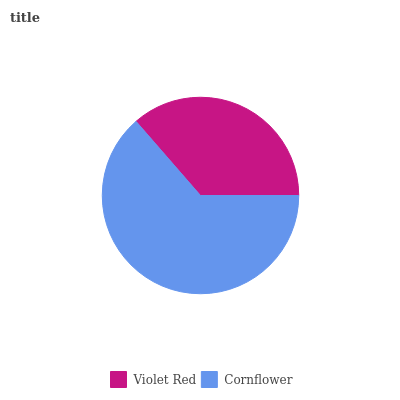Is Violet Red the minimum?
Answer yes or no. Yes. Is Cornflower the maximum?
Answer yes or no. Yes. Is Cornflower the minimum?
Answer yes or no. No. Is Cornflower greater than Violet Red?
Answer yes or no. Yes. Is Violet Red less than Cornflower?
Answer yes or no. Yes. Is Violet Red greater than Cornflower?
Answer yes or no. No. Is Cornflower less than Violet Red?
Answer yes or no. No. Is Cornflower the high median?
Answer yes or no. Yes. Is Violet Red the low median?
Answer yes or no. Yes. Is Violet Red the high median?
Answer yes or no. No. Is Cornflower the low median?
Answer yes or no. No. 